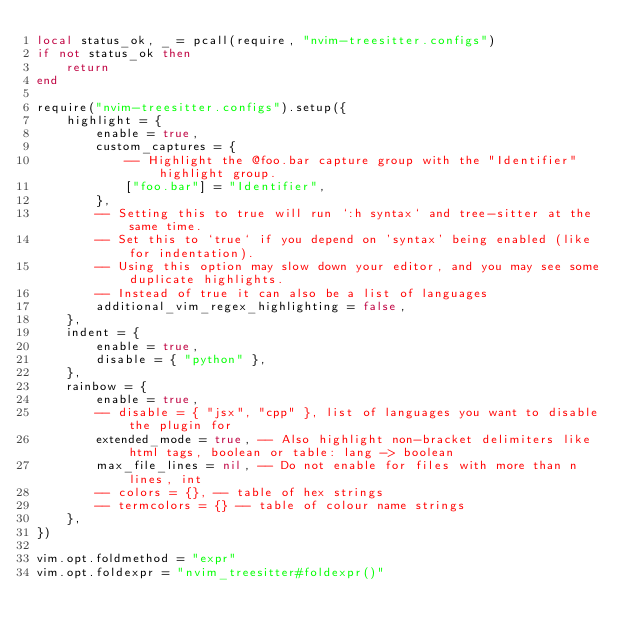<code> <loc_0><loc_0><loc_500><loc_500><_Lua_>local status_ok, _ = pcall(require, "nvim-treesitter.configs")
if not status_ok then
	return
end

require("nvim-treesitter.configs").setup({
	highlight = {
		enable = true,
		custom_captures = {
			-- Highlight the @foo.bar capture group with the "Identifier" highlight group.
			["foo.bar"] = "Identifier",
		},
		-- Setting this to true will run `:h syntax` and tree-sitter at the same time.
		-- Set this to `true` if you depend on 'syntax' being enabled (like for indentation).
		-- Using this option may slow down your editor, and you may see some duplicate highlights.
		-- Instead of true it can also be a list of languages
		additional_vim_regex_highlighting = false,
	},
	indent = {
		enable = true,
		disable = { "python" },
	},
	rainbow = {
		enable = true,
		-- disable = { "jsx", "cpp" }, list of languages you want to disable the plugin for
		extended_mode = true, -- Also highlight non-bracket delimiters like html tags, boolean or table: lang -> boolean
		max_file_lines = nil, -- Do not enable for files with more than n lines, int
		-- colors = {}, -- table of hex strings
		-- termcolors = {} -- table of colour name strings
	},
})

vim.opt.foldmethod = "expr"
vim.opt.foldexpr = "nvim_treesitter#foldexpr()"
</code> 